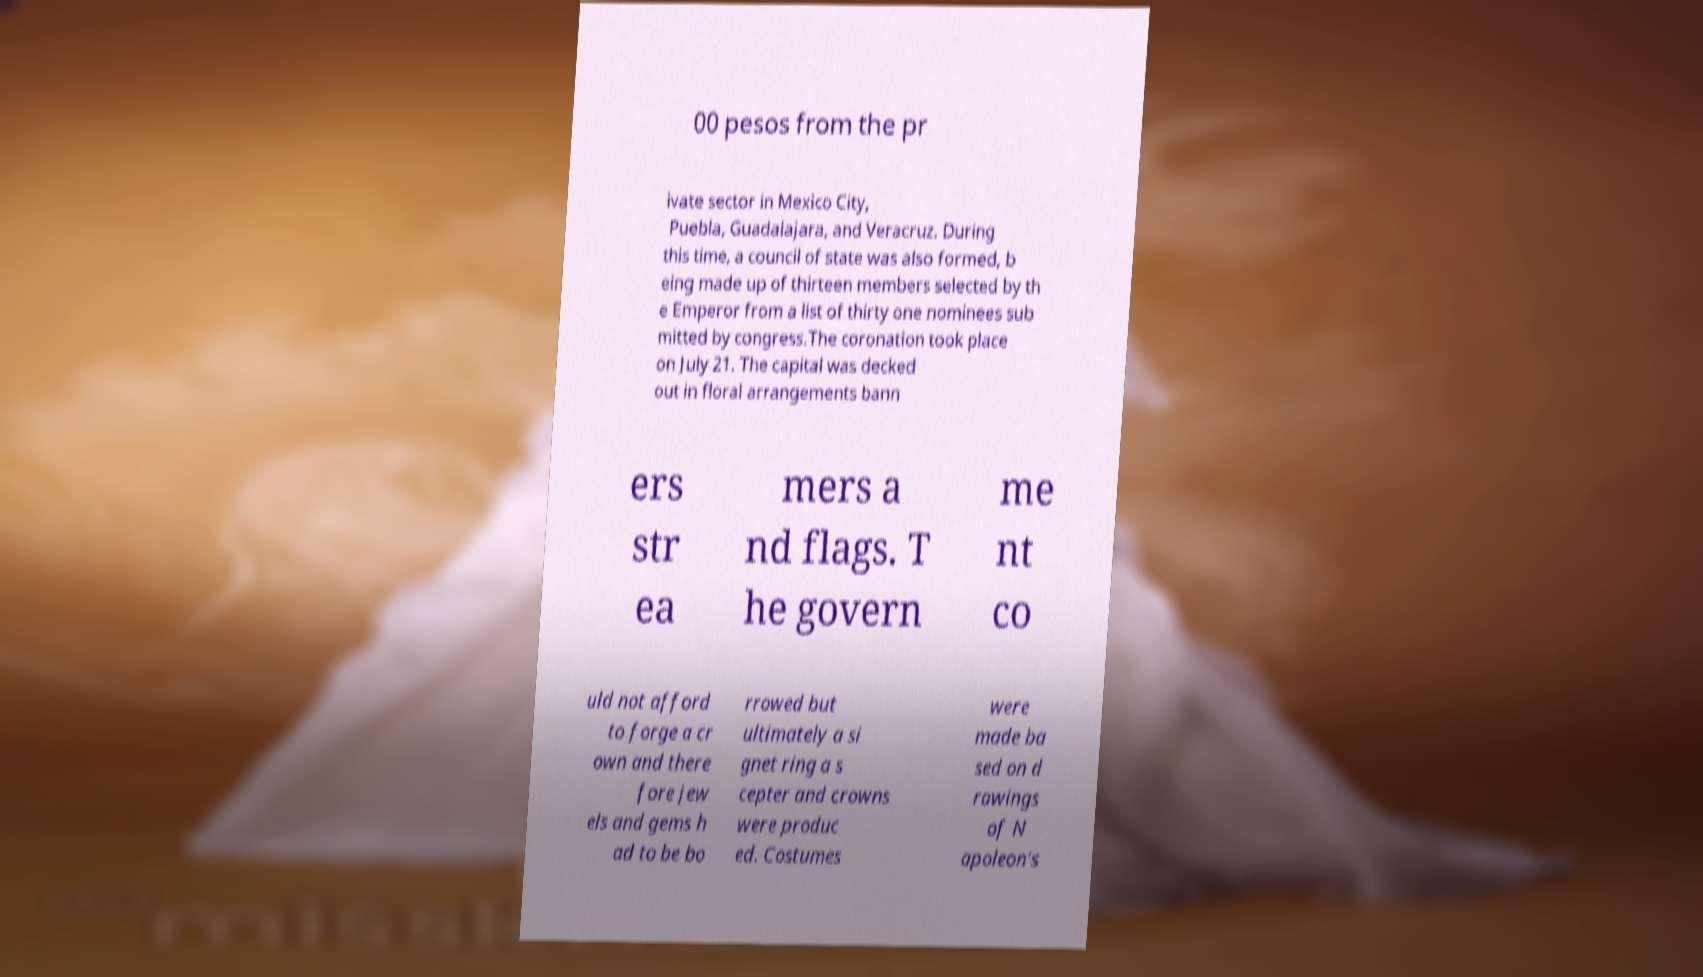Can you read and provide the text displayed in the image?This photo seems to have some interesting text. Can you extract and type it out for me? 00 pesos from the pr ivate sector in Mexico City, Puebla, Guadalajara, and Veracruz. During this time, a council of state was also formed, b eing made up of thirteen members selected by th e Emperor from a list of thirty one nominees sub mitted by congress.The coronation took place on July 21. The capital was decked out in floral arrangements bann ers str ea mers a nd flags. T he govern me nt co uld not afford to forge a cr own and there fore jew els and gems h ad to be bo rrowed but ultimately a si gnet ring a s cepter and crowns were produc ed. Costumes were made ba sed on d rawings of N apoleon's 